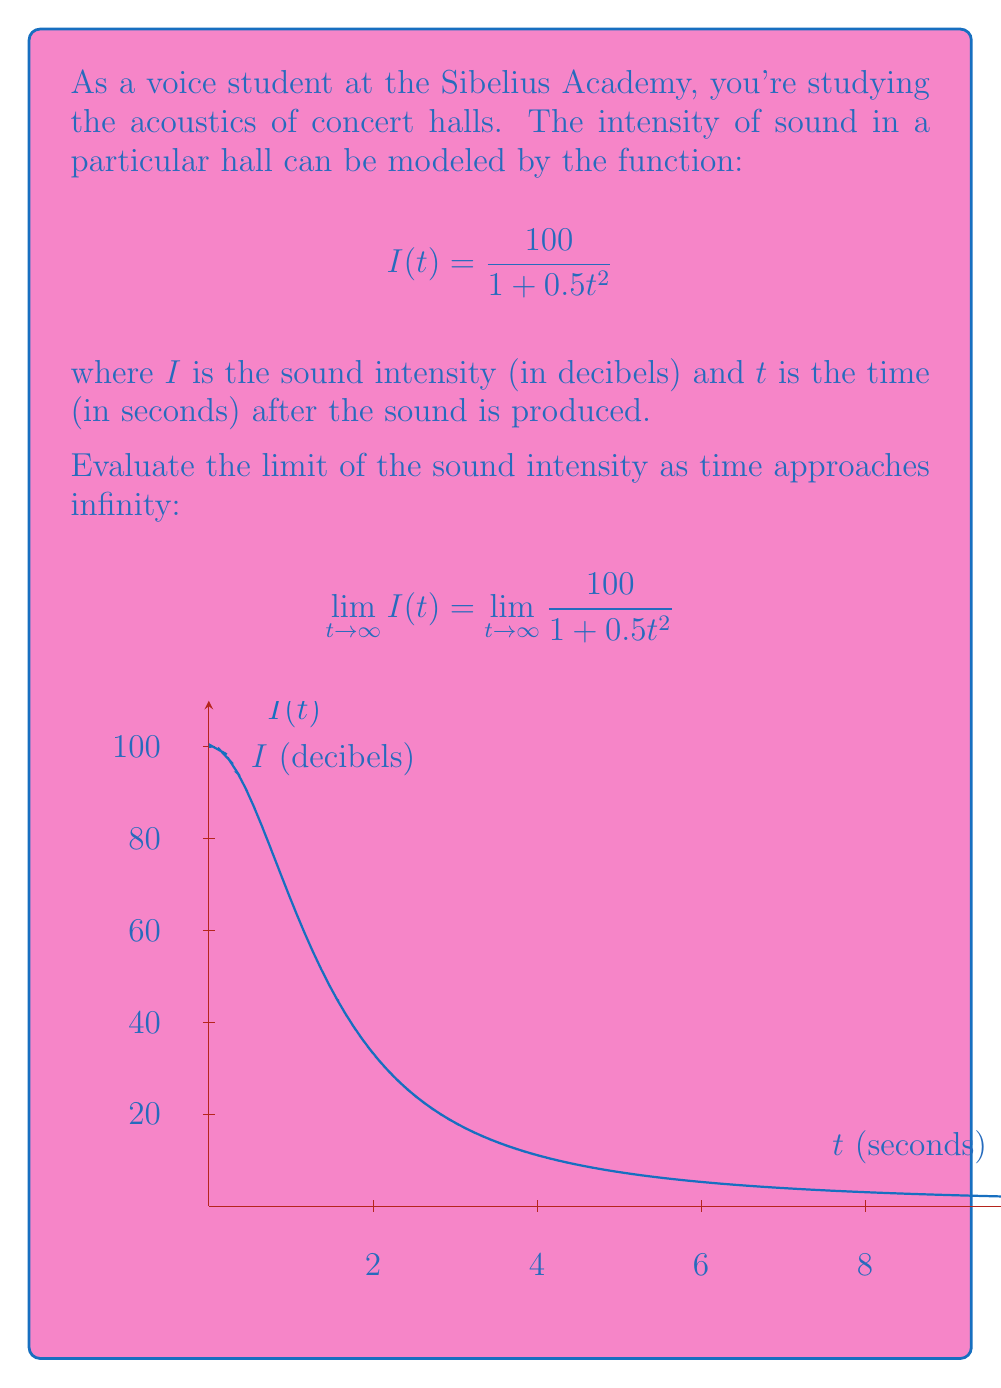Teach me how to tackle this problem. Let's approach this step-by-step:

1) We're dealing with the limit:
   $$\lim_{t \to \infty} \frac{100}{1 + 0.5t^2}$$

2) As $t$ approaches infinity, $0.5t^2$ in the denominator will grow much larger than 1.

3) We can factor out $t^2$ from the denominator:
   $$\lim_{t \to \infty} \frac{100}{t^2(\frac{1}{t^2} + 0.5)}$$

4) This can be rewritten as:
   $$\lim_{t \to \infty} \frac{100/t^2}{1/t^2 + 0.5}$$

5) As $t \to \infty$, $1/t^2 \to 0$, so the denominator approaches 0.5.

6) In the numerator, $100/t^2 \to 0$ as $t \to \infty$.

7) Therefore, we have:
   $$\lim_{t \to \infty} \frac{100}{1 + 0.5t^2} = \frac{0}{0.5} = 0$$

This means that as time increases indefinitely, the sound intensity in the concert hall approaches zero, which aligns with our understanding of sound decay in enclosed spaces.
Answer: $0$ 